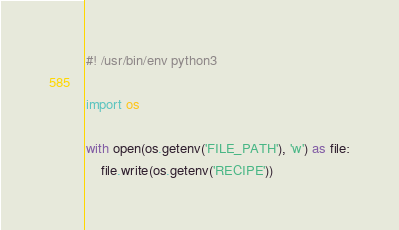<code> <loc_0><loc_0><loc_500><loc_500><_Python_>#! /usr/bin/env python3

import os

with open(os.getenv('FILE_PATH'), 'w') as file:
    file.write(os.getenv('RECIPE'))</code> 